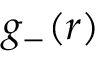<formula> <loc_0><loc_0><loc_500><loc_500>g _ { - } ( r )</formula> 